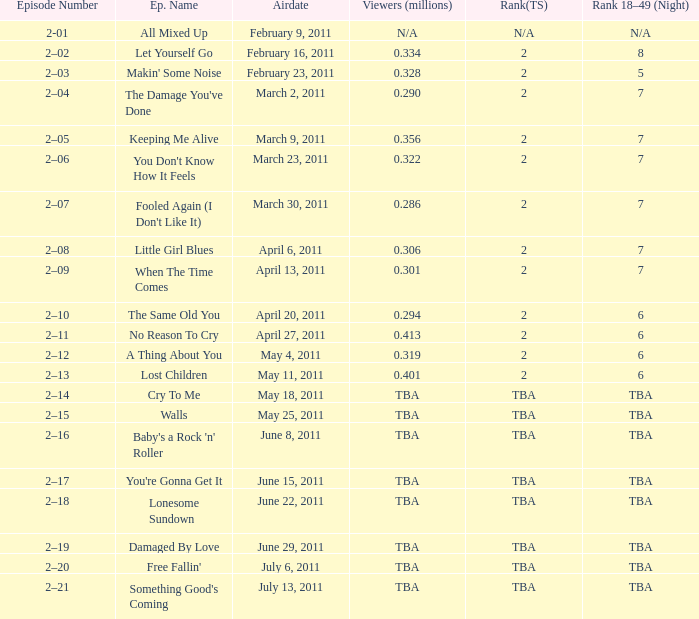What is the total rank on airdate march 30, 2011? 1.0. 